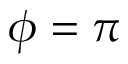<formula> <loc_0><loc_0><loc_500><loc_500>\phi = \pi</formula> 